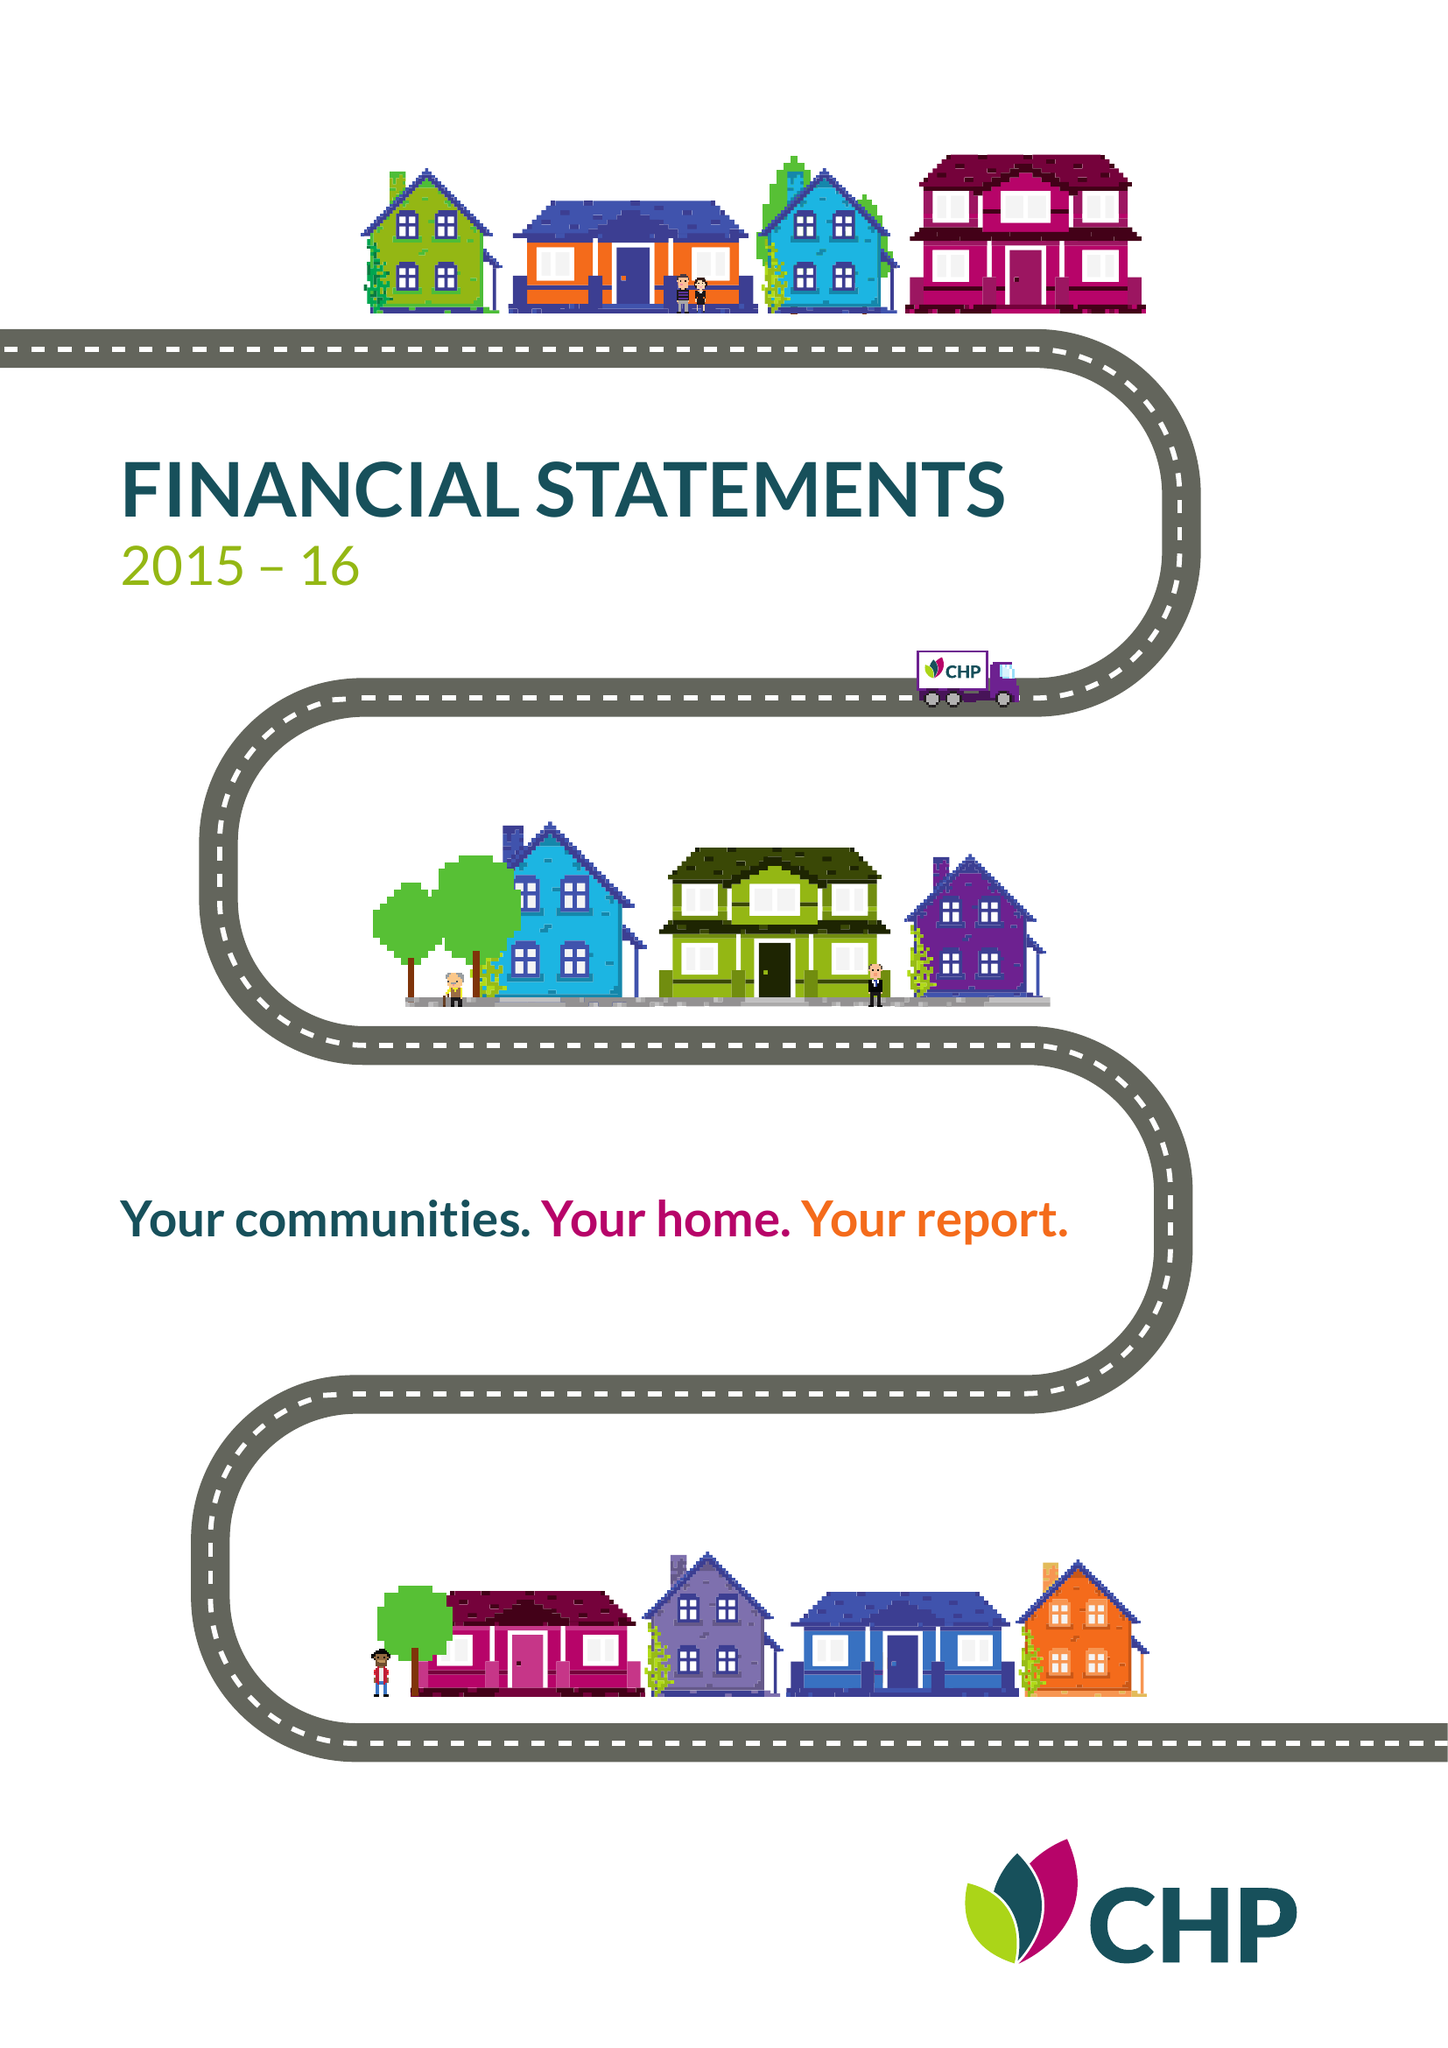What is the value for the report_date?
Answer the question using a single word or phrase. 2016-03-31 